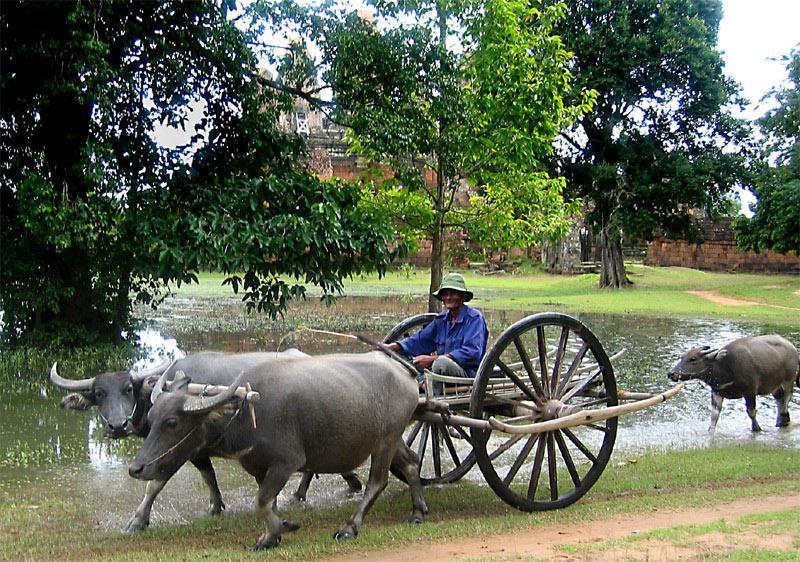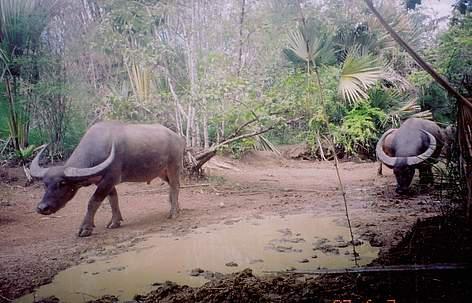The first image is the image on the left, the second image is the image on the right. Given the left and right images, does the statement "The left image shows one adult in a hat holding a stick behind a team of two hitched oxen walking in a wet area." hold true? Answer yes or no. Yes. 